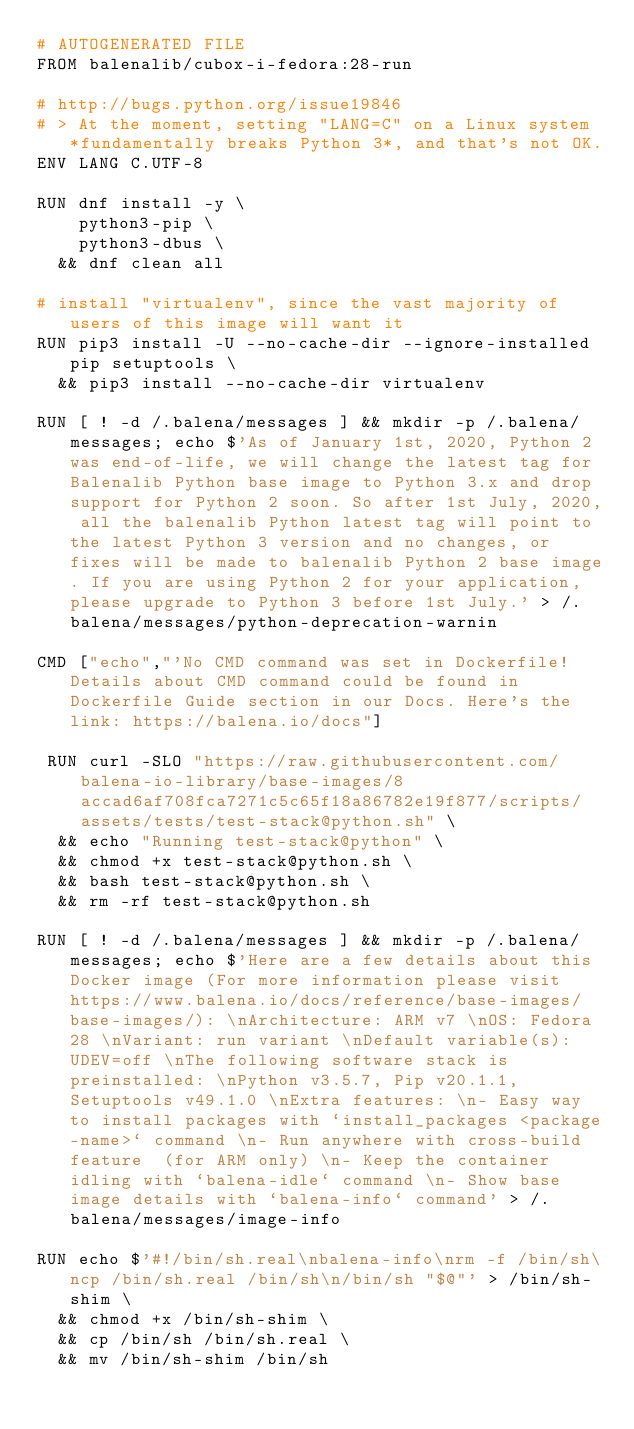Convert code to text. <code><loc_0><loc_0><loc_500><loc_500><_Dockerfile_># AUTOGENERATED FILE
FROM balenalib/cubox-i-fedora:28-run

# http://bugs.python.org/issue19846
# > At the moment, setting "LANG=C" on a Linux system *fundamentally breaks Python 3*, and that's not OK.
ENV LANG C.UTF-8

RUN dnf install -y \
		python3-pip \
		python3-dbus \
	&& dnf clean all

# install "virtualenv", since the vast majority of users of this image will want it
RUN pip3 install -U --no-cache-dir --ignore-installed pip setuptools \
	&& pip3 install --no-cache-dir virtualenv

RUN [ ! -d /.balena/messages ] && mkdir -p /.balena/messages; echo $'As of January 1st, 2020, Python 2 was end-of-life, we will change the latest tag for Balenalib Python base image to Python 3.x and drop support for Python 2 soon. So after 1st July, 2020, all the balenalib Python latest tag will point to the latest Python 3 version and no changes, or fixes will be made to balenalib Python 2 base image. If you are using Python 2 for your application, please upgrade to Python 3 before 1st July.' > /.balena/messages/python-deprecation-warnin

CMD ["echo","'No CMD command was set in Dockerfile! Details about CMD command could be found in Dockerfile Guide section in our Docs. Here's the link: https://balena.io/docs"]

 RUN curl -SLO "https://raw.githubusercontent.com/balena-io-library/base-images/8accad6af708fca7271c5c65f18a86782e19f877/scripts/assets/tests/test-stack@python.sh" \
  && echo "Running test-stack@python" \
  && chmod +x test-stack@python.sh \
  && bash test-stack@python.sh \
  && rm -rf test-stack@python.sh 

RUN [ ! -d /.balena/messages ] && mkdir -p /.balena/messages; echo $'Here are a few details about this Docker image (For more information please visit https://www.balena.io/docs/reference/base-images/base-images/): \nArchitecture: ARM v7 \nOS: Fedora 28 \nVariant: run variant \nDefault variable(s): UDEV=off \nThe following software stack is preinstalled: \nPython v3.5.7, Pip v20.1.1, Setuptools v49.1.0 \nExtra features: \n- Easy way to install packages with `install_packages <package-name>` command \n- Run anywhere with cross-build feature  (for ARM only) \n- Keep the container idling with `balena-idle` command \n- Show base image details with `balena-info` command' > /.balena/messages/image-info

RUN echo $'#!/bin/sh.real\nbalena-info\nrm -f /bin/sh\ncp /bin/sh.real /bin/sh\n/bin/sh "$@"' > /bin/sh-shim \
	&& chmod +x /bin/sh-shim \
	&& cp /bin/sh /bin/sh.real \
	&& mv /bin/sh-shim /bin/sh</code> 